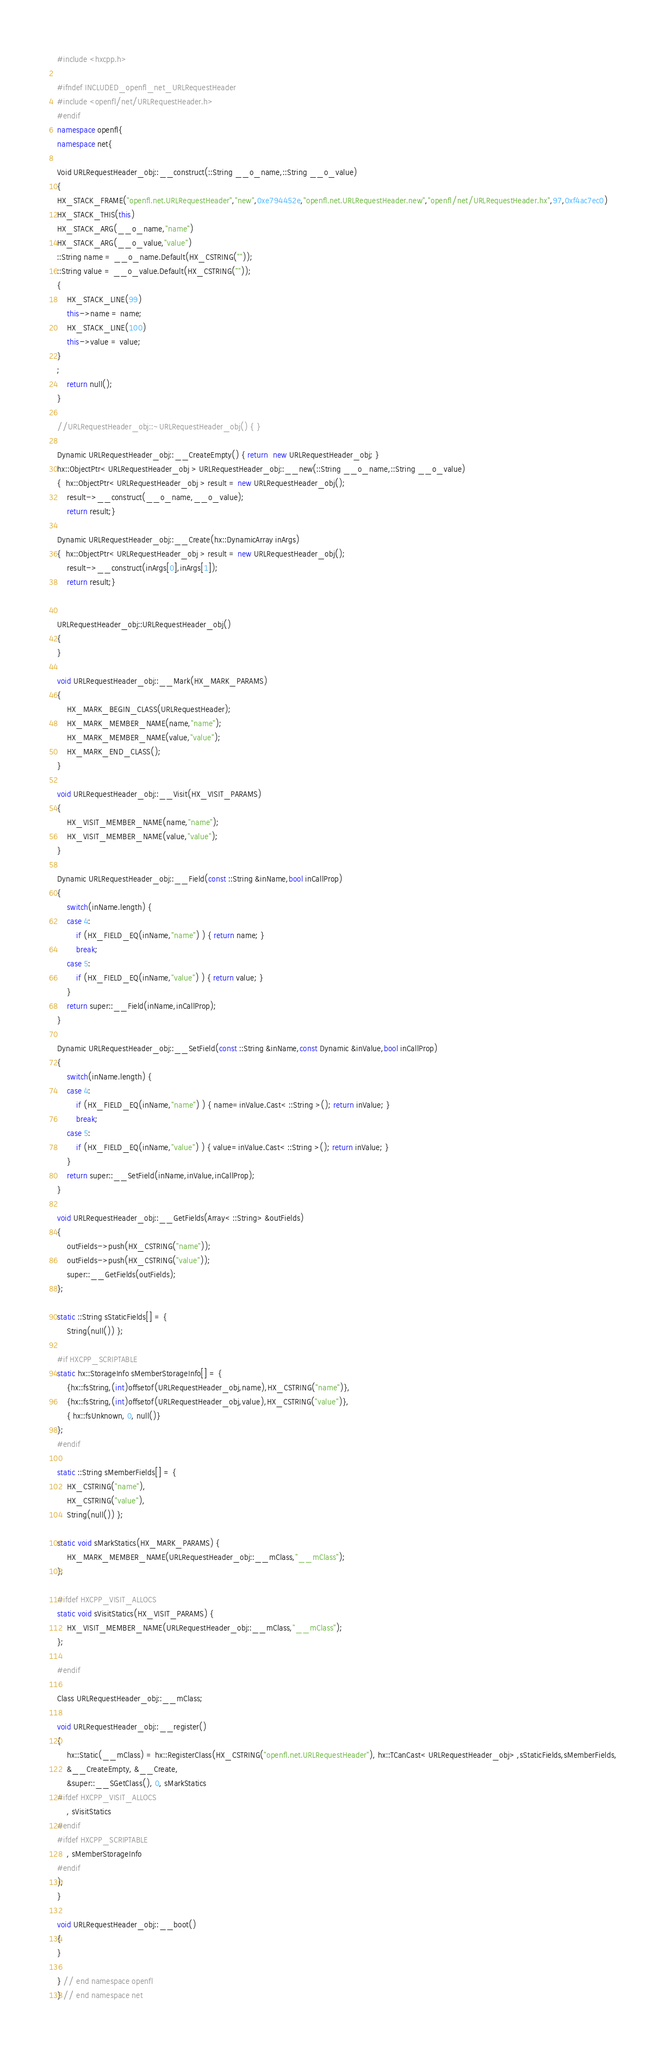<code> <loc_0><loc_0><loc_500><loc_500><_C++_>#include <hxcpp.h>

#ifndef INCLUDED_openfl_net_URLRequestHeader
#include <openfl/net/URLRequestHeader.h>
#endif
namespace openfl{
namespace net{

Void URLRequestHeader_obj::__construct(::String __o_name,::String __o_value)
{
HX_STACK_FRAME("openfl.net.URLRequestHeader","new",0xe794452e,"openfl.net.URLRequestHeader.new","openfl/net/URLRequestHeader.hx",97,0xf4ac7ec0)
HX_STACK_THIS(this)
HX_STACK_ARG(__o_name,"name")
HX_STACK_ARG(__o_value,"value")
::String name = __o_name.Default(HX_CSTRING(""));
::String value = __o_value.Default(HX_CSTRING(""));
{
	HX_STACK_LINE(99)
	this->name = name;
	HX_STACK_LINE(100)
	this->value = value;
}
;
	return null();
}

//URLRequestHeader_obj::~URLRequestHeader_obj() { }

Dynamic URLRequestHeader_obj::__CreateEmpty() { return  new URLRequestHeader_obj; }
hx::ObjectPtr< URLRequestHeader_obj > URLRequestHeader_obj::__new(::String __o_name,::String __o_value)
{  hx::ObjectPtr< URLRequestHeader_obj > result = new URLRequestHeader_obj();
	result->__construct(__o_name,__o_value);
	return result;}

Dynamic URLRequestHeader_obj::__Create(hx::DynamicArray inArgs)
{  hx::ObjectPtr< URLRequestHeader_obj > result = new URLRequestHeader_obj();
	result->__construct(inArgs[0],inArgs[1]);
	return result;}


URLRequestHeader_obj::URLRequestHeader_obj()
{
}

void URLRequestHeader_obj::__Mark(HX_MARK_PARAMS)
{
	HX_MARK_BEGIN_CLASS(URLRequestHeader);
	HX_MARK_MEMBER_NAME(name,"name");
	HX_MARK_MEMBER_NAME(value,"value");
	HX_MARK_END_CLASS();
}

void URLRequestHeader_obj::__Visit(HX_VISIT_PARAMS)
{
	HX_VISIT_MEMBER_NAME(name,"name");
	HX_VISIT_MEMBER_NAME(value,"value");
}

Dynamic URLRequestHeader_obj::__Field(const ::String &inName,bool inCallProp)
{
	switch(inName.length) {
	case 4:
		if (HX_FIELD_EQ(inName,"name") ) { return name; }
		break;
	case 5:
		if (HX_FIELD_EQ(inName,"value") ) { return value; }
	}
	return super::__Field(inName,inCallProp);
}

Dynamic URLRequestHeader_obj::__SetField(const ::String &inName,const Dynamic &inValue,bool inCallProp)
{
	switch(inName.length) {
	case 4:
		if (HX_FIELD_EQ(inName,"name") ) { name=inValue.Cast< ::String >(); return inValue; }
		break;
	case 5:
		if (HX_FIELD_EQ(inName,"value") ) { value=inValue.Cast< ::String >(); return inValue; }
	}
	return super::__SetField(inName,inValue,inCallProp);
}

void URLRequestHeader_obj::__GetFields(Array< ::String> &outFields)
{
	outFields->push(HX_CSTRING("name"));
	outFields->push(HX_CSTRING("value"));
	super::__GetFields(outFields);
};

static ::String sStaticFields[] = {
	String(null()) };

#if HXCPP_SCRIPTABLE
static hx::StorageInfo sMemberStorageInfo[] = {
	{hx::fsString,(int)offsetof(URLRequestHeader_obj,name),HX_CSTRING("name")},
	{hx::fsString,(int)offsetof(URLRequestHeader_obj,value),HX_CSTRING("value")},
	{ hx::fsUnknown, 0, null()}
};
#endif

static ::String sMemberFields[] = {
	HX_CSTRING("name"),
	HX_CSTRING("value"),
	String(null()) };

static void sMarkStatics(HX_MARK_PARAMS) {
	HX_MARK_MEMBER_NAME(URLRequestHeader_obj::__mClass,"__mClass");
};

#ifdef HXCPP_VISIT_ALLOCS
static void sVisitStatics(HX_VISIT_PARAMS) {
	HX_VISIT_MEMBER_NAME(URLRequestHeader_obj::__mClass,"__mClass");
};

#endif

Class URLRequestHeader_obj::__mClass;

void URLRequestHeader_obj::__register()
{
	hx::Static(__mClass) = hx::RegisterClass(HX_CSTRING("openfl.net.URLRequestHeader"), hx::TCanCast< URLRequestHeader_obj> ,sStaticFields,sMemberFields,
	&__CreateEmpty, &__Create,
	&super::__SGetClass(), 0, sMarkStatics
#ifdef HXCPP_VISIT_ALLOCS
    , sVisitStatics
#endif
#ifdef HXCPP_SCRIPTABLE
    , sMemberStorageInfo
#endif
);
}

void URLRequestHeader_obj::__boot()
{
}

} // end namespace openfl
} // end namespace net
</code> 